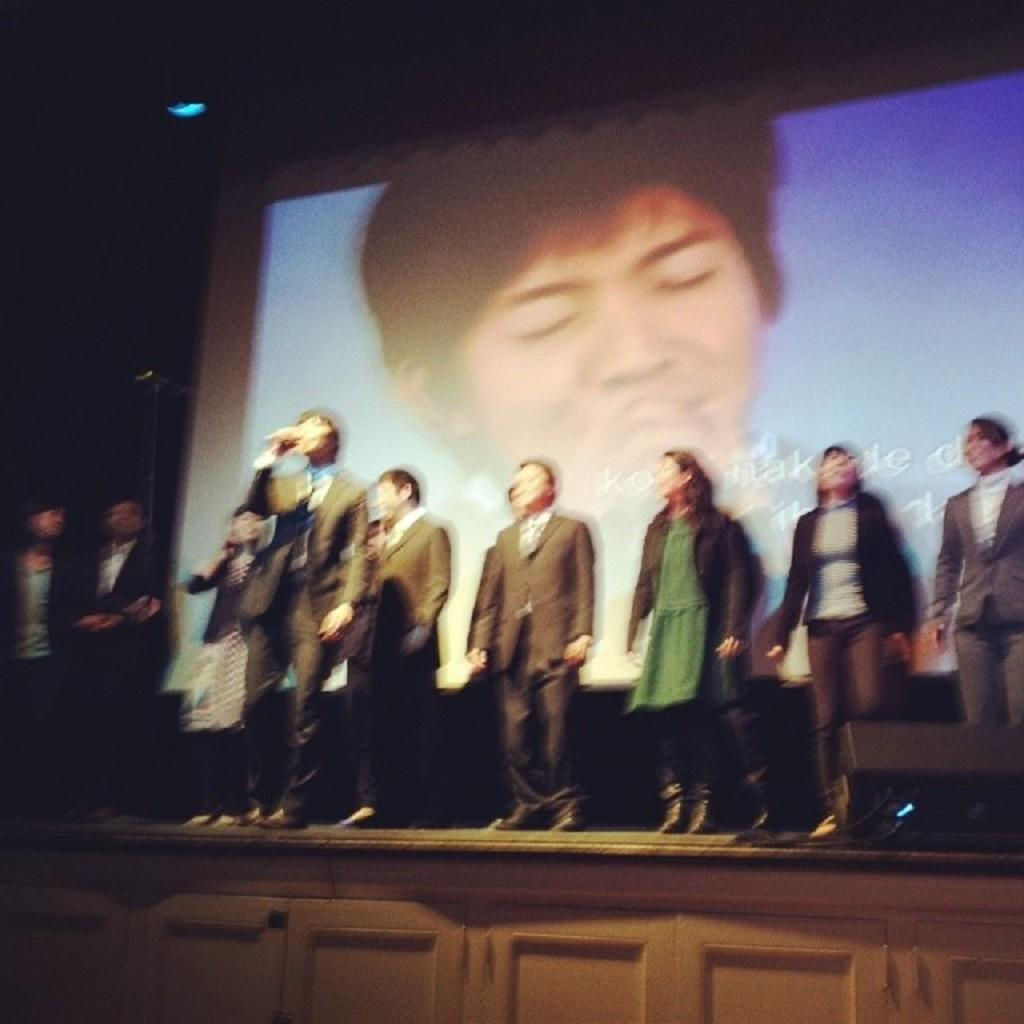What is happening on the stage in the image? There are people standing on the stage in the image. What is located behind the people on the stage? There is a projector screen behind the people on the stage. What type of star can be seen on the projector screen in the image? There is no star visible on the projector screen in the image. How many nuts are present on the stage in the image? There are no nuts present on the stage in the image. 